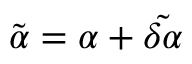Convert formula to latex. <formula><loc_0><loc_0><loc_500><loc_500>\tilde { \alpha } = \alpha + \tilde { \delta \alpha }</formula> 